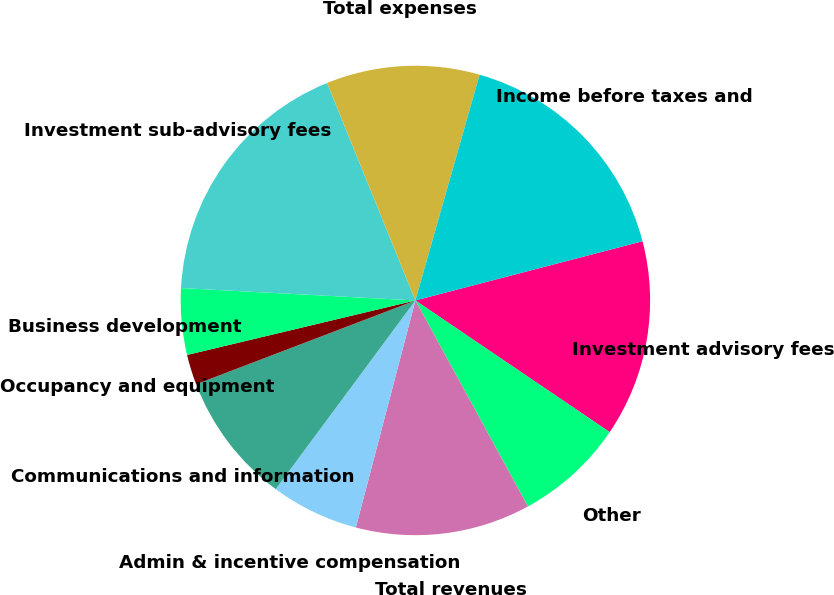Convert chart. <chart><loc_0><loc_0><loc_500><loc_500><pie_chart><fcel>Investment advisory fees<fcel>Other<fcel>Total revenues<fcel>Admin & incentive compensation<fcel>Communications and information<fcel>Occupancy and equipment<fcel>Business development<fcel>Investment sub-advisory fees<fcel>Total expenses<fcel>Income before taxes and<nl><fcel>13.54%<fcel>7.56%<fcel>12.04%<fcel>6.06%<fcel>9.05%<fcel>2.08%<fcel>4.57%<fcel>18.02%<fcel>10.55%<fcel>16.53%<nl></chart> 